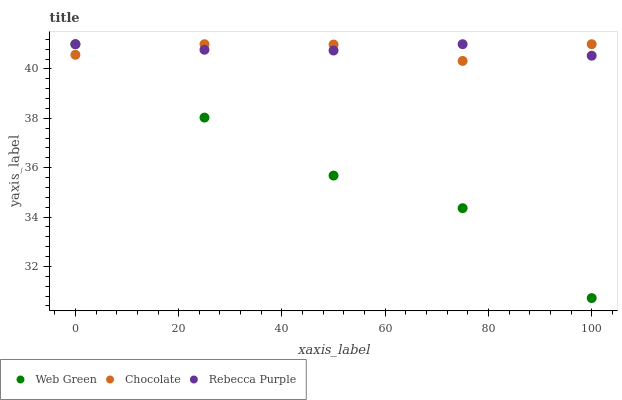Does Web Green have the minimum area under the curve?
Answer yes or no. Yes. Does Rebecca Purple have the maximum area under the curve?
Answer yes or no. Yes. Does Chocolate have the minimum area under the curve?
Answer yes or no. No. Does Chocolate have the maximum area under the curve?
Answer yes or no. No. Is Rebecca Purple the smoothest?
Answer yes or no. Yes. Is Web Green the roughest?
Answer yes or no. Yes. Is Chocolate the smoothest?
Answer yes or no. No. Is Chocolate the roughest?
Answer yes or no. No. Does Web Green have the lowest value?
Answer yes or no. Yes. Does Chocolate have the lowest value?
Answer yes or no. No. Does Chocolate have the highest value?
Answer yes or no. Yes. Does Web Green intersect Rebecca Purple?
Answer yes or no. Yes. Is Web Green less than Rebecca Purple?
Answer yes or no. No. Is Web Green greater than Rebecca Purple?
Answer yes or no. No. 